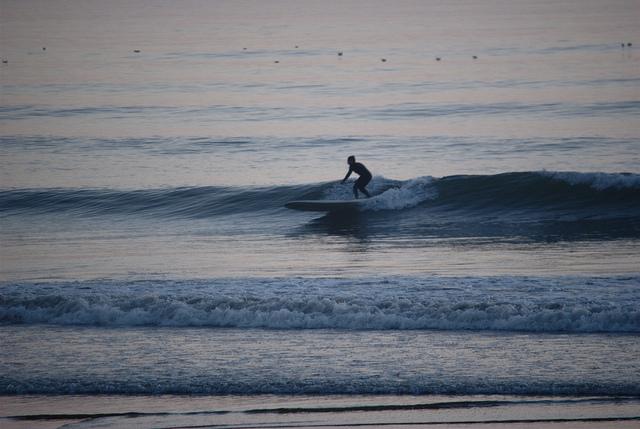Is it bright and sunny?
Write a very short answer. No. Is the man traveling towards the shore?
Give a very brief answer. Yes. What is the man doing?
Answer briefly. Surfing. 